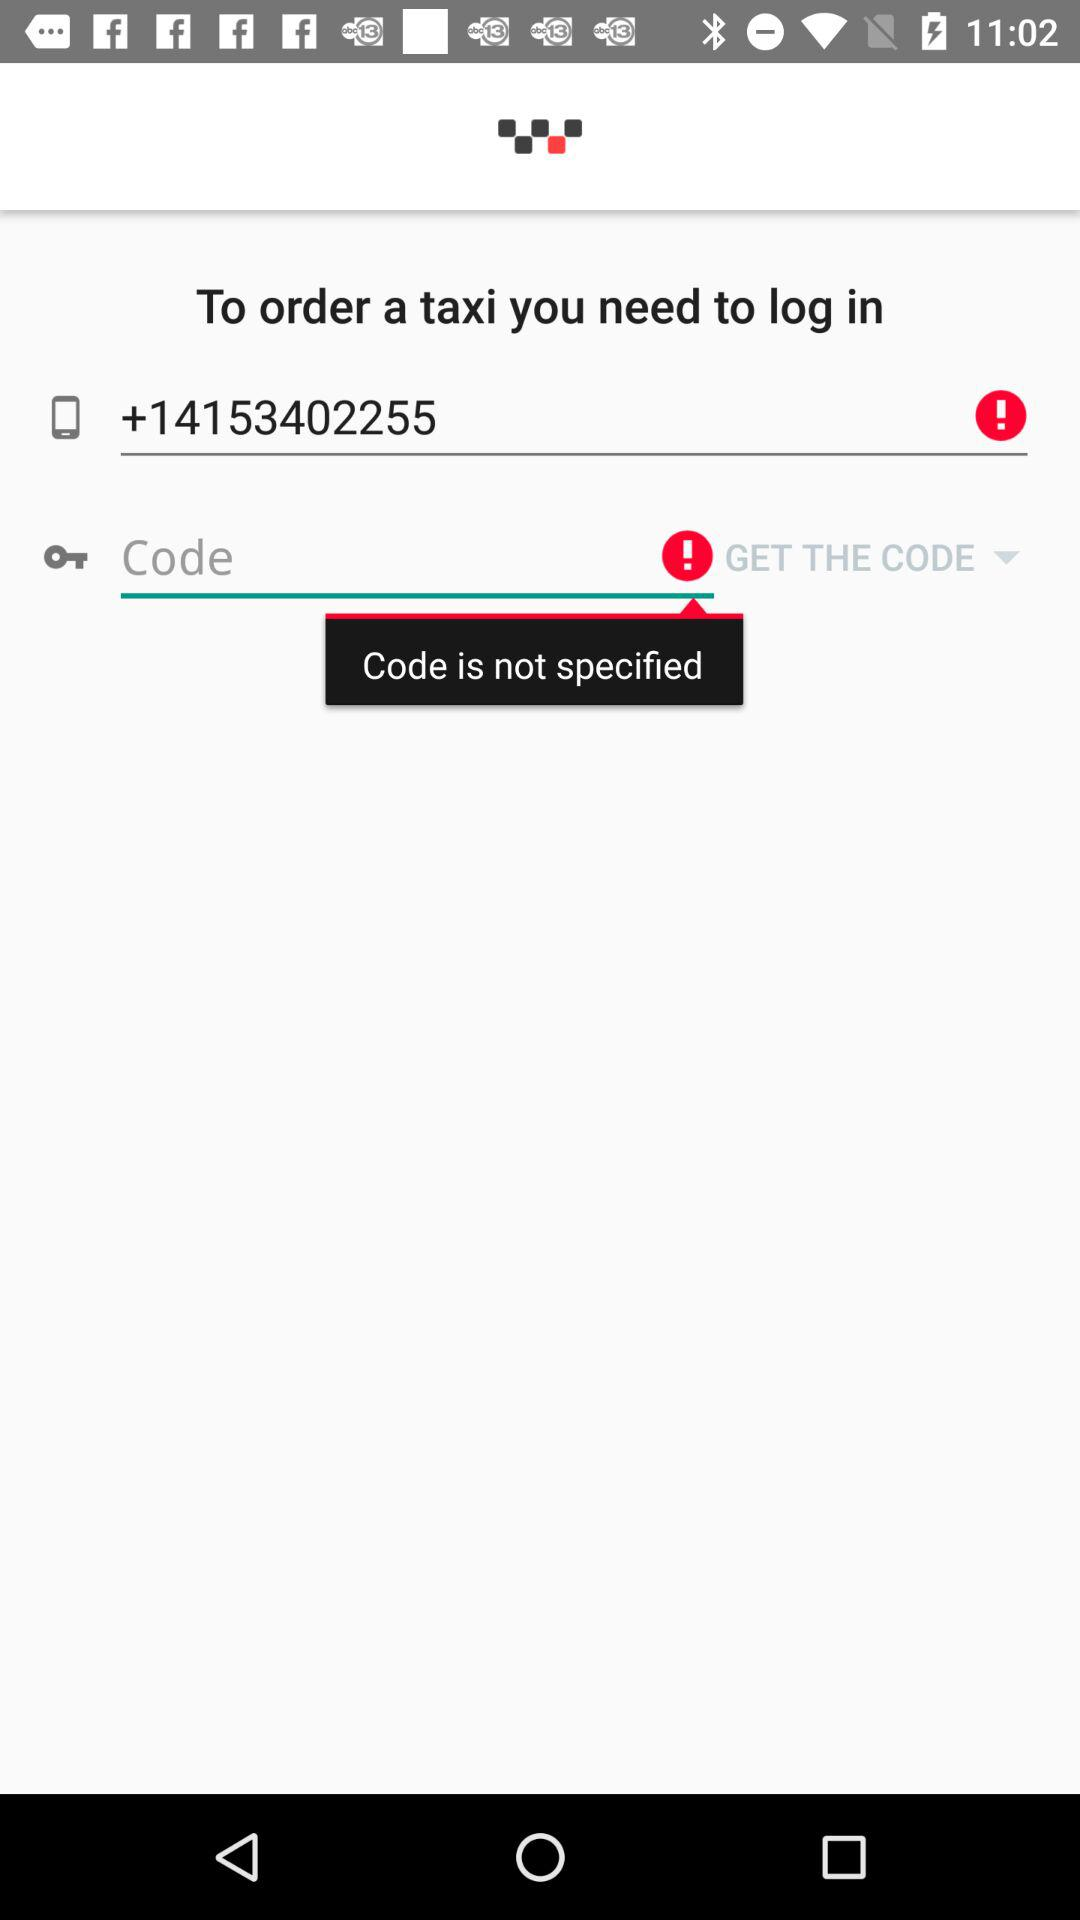How many input fields are on the screen?
Answer the question using a single word or phrase. 2 